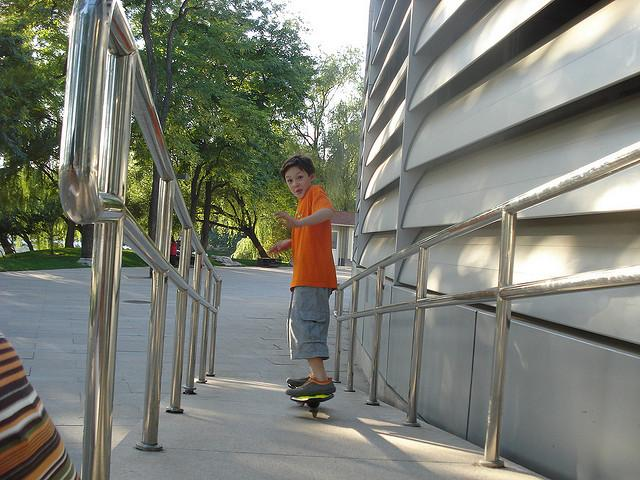What group of people is the ramp here constructed for? Please explain your reasoning. handicapped people. There are no stairs. a wheelchair can roll down the ramp easily. people with disabilities ride in wheelchairs. 